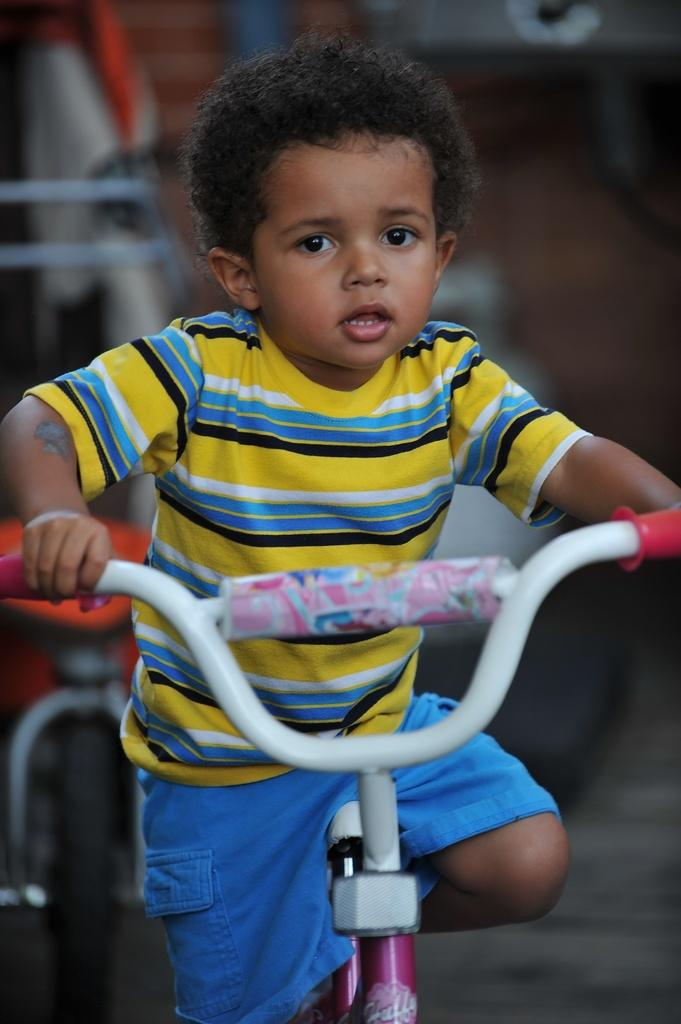What is the main subject of the image? The main subject of the image is a kid. What is the kid wearing? The kid is wearing a yellow T-shirt. What activity is the kid engaged in? The kid is riding a bicycle. Can you describe the bicycle? The bicycle is pink and white in color. What is visible at the bottom of the image? There is a road at the bottom of the image. How would you describe the background of the image? The background of the image is blurred. What time of day is it in the image, and how many deer are visible? The time of day is not mentioned in the image, and there are no deer visible. 